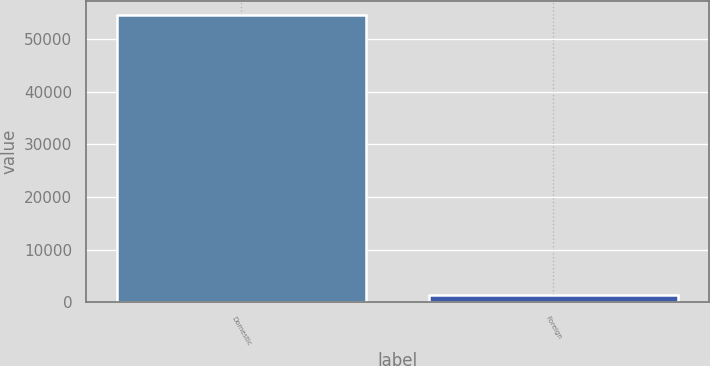Convert chart to OTSL. <chart><loc_0><loc_0><loc_500><loc_500><bar_chart><fcel>Domestic<fcel>Foreign<nl><fcel>54542<fcel>1319<nl></chart> 